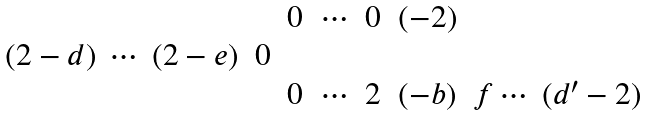<formula> <loc_0><loc_0><loc_500><loc_500>\begin{matrix} & & 0 & \cdots & 0 & ( - 2 ) & \\ ( 2 - d ) \ \cdots \ ( 2 - e ) & 0 & & & & & \\ & & 0 & \cdots & 2 & ( - b ) & f \cdots \ ( d ^ { \prime } - 2 ) \end{matrix}</formula> 